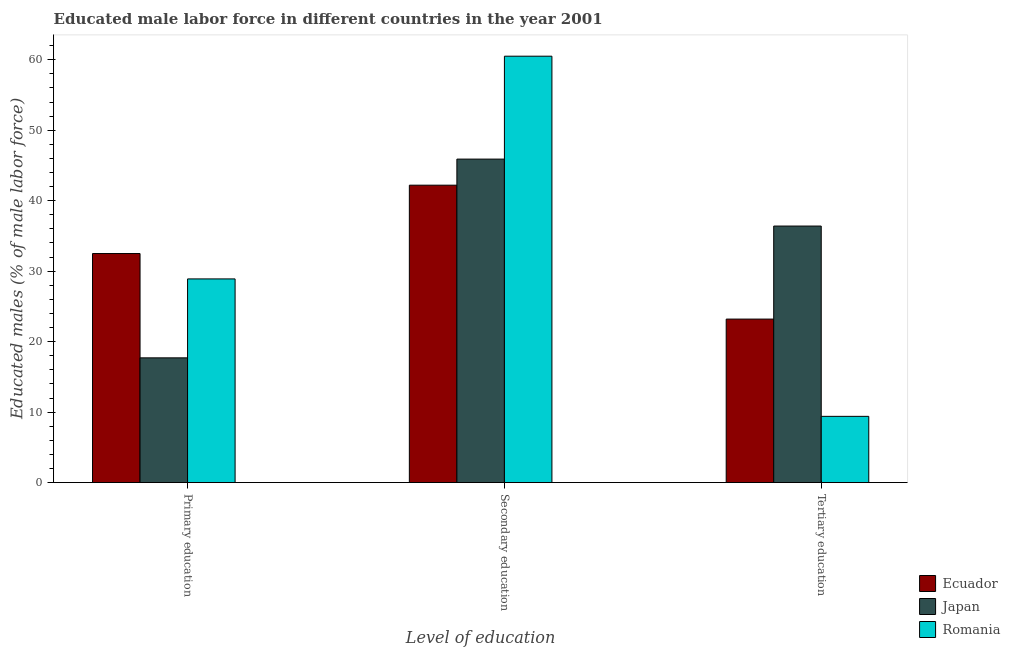How many different coloured bars are there?
Keep it short and to the point. 3. Are the number of bars per tick equal to the number of legend labels?
Your answer should be very brief. Yes. Are the number of bars on each tick of the X-axis equal?
Your answer should be compact. Yes. How many bars are there on the 1st tick from the left?
Your answer should be very brief. 3. What is the label of the 2nd group of bars from the left?
Offer a terse response. Secondary education. What is the percentage of male labor force who received secondary education in Romania?
Offer a very short reply. 60.5. Across all countries, what is the maximum percentage of male labor force who received primary education?
Offer a terse response. 32.5. Across all countries, what is the minimum percentage of male labor force who received tertiary education?
Offer a terse response. 9.4. In which country was the percentage of male labor force who received tertiary education maximum?
Offer a terse response. Japan. What is the total percentage of male labor force who received tertiary education in the graph?
Offer a very short reply. 69. What is the difference between the percentage of male labor force who received tertiary education in Romania and that in Japan?
Your answer should be compact. -27. What is the difference between the percentage of male labor force who received secondary education in Romania and the percentage of male labor force who received primary education in Japan?
Ensure brevity in your answer.  42.8. What is the average percentage of male labor force who received primary education per country?
Ensure brevity in your answer.  26.37. What is the difference between the percentage of male labor force who received tertiary education and percentage of male labor force who received primary education in Japan?
Make the answer very short. 18.7. What is the ratio of the percentage of male labor force who received tertiary education in Romania to that in Ecuador?
Offer a terse response. 0.41. Is the difference between the percentage of male labor force who received secondary education in Japan and Ecuador greater than the difference between the percentage of male labor force who received tertiary education in Japan and Ecuador?
Offer a very short reply. No. What is the difference between the highest and the second highest percentage of male labor force who received primary education?
Provide a short and direct response. 3.6. What is the difference between the highest and the lowest percentage of male labor force who received primary education?
Your answer should be compact. 14.8. What does the 2nd bar from the left in Tertiary education represents?
Provide a succinct answer. Japan. What does the 3rd bar from the right in Primary education represents?
Give a very brief answer. Ecuador. How many bars are there?
Provide a succinct answer. 9. Does the graph contain grids?
Your answer should be very brief. No. How are the legend labels stacked?
Offer a very short reply. Vertical. What is the title of the graph?
Give a very brief answer. Educated male labor force in different countries in the year 2001. Does "Slovak Republic" appear as one of the legend labels in the graph?
Provide a succinct answer. No. What is the label or title of the X-axis?
Give a very brief answer. Level of education. What is the label or title of the Y-axis?
Offer a very short reply. Educated males (% of male labor force). What is the Educated males (% of male labor force) of Ecuador in Primary education?
Keep it short and to the point. 32.5. What is the Educated males (% of male labor force) in Japan in Primary education?
Provide a short and direct response. 17.7. What is the Educated males (% of male labor force) in Romania in Primary education?
Provide a short and direct response. 28.9. What is the Educated males (% of male labor force) of Ecuador in Secondary education?
Provide a short and direct response. 42.2. What is the Educated males (% of male labor force) of Japan in Secondary education?
Ensure brevity in your answer.  45.9. What is the Educated males (% of male labor force) in Romania in Secondary education?
Offer a very short reply. 60.5. What is the Educated males (% of male labor force) of Ecuador in Tertiary education?
Your answer should be very brief. 23.2. What is the Educated males (% of male labor force) in Japan in Tertiary education?
Your answer should be compact. 36.4. What is the Educated males (% of male labor force) in Romania in Tertiary education?
Keep it short and to the point. 9.4. Across all Level of education, what is the maximum Educated males (% of male labor force) of Ecuador?
Keep it short and to the point. 42.2. Across all Level of education, what is the maximum Educated males (% of male labor force) in Japan?
Ensure brevity in your answer.  45.9. Across all Level of education, what is the maximum Educated males (% of male labor force) of Romania?
Make the answer very short. 60.5. Across all Level of education, what is the minimum Educated males (% of male labor force) of Ecuador?
Make the answer very short. 23.2. Across all Level of education, what is the minimum Educated males (% of male labor force) of Japan?
Make the answer very short. 17.7. Across all Level of education, what is the minimum Educated males (% of male labor force) in Romania?
Provide a succinct answer. 9.4. What is the total Educated males (% of male labor force) of Ecuador in the graph?
Offer a terse response. 97.9. What is the total Educated males (% of male labor force) in Romania in the graph?
Offer a terse response. 98.8. What is the difference between the Educated males (% of male labor force) of Ecuador in Primary education and that in Secondary education?
Keep it short and to the point. -9.7. What is the difference between the Educated males (% of male labor force) in Japan in Primary education and that in Secondary education?
Offer a very short reply. -28.2. What is the difference between the Educated males (% of male labor force) in Romania in Primary education and that in Secondary education?
Give a very brief answer. -31.6. What is the difference between the Educated males (% of male labor force) of Japan in Primary education and that in Tertiary education?
Offer a terse response. -18.7. What is the difference between the Educated males (% of male labor force) in Romania in Primary education and that in Tertiary education?
Your answer should be very brief. 19.5. What is the difference between the Educated males (% of male labor force) in Ecuador in Secondary education and that in Tertiary education?
Offer a terse response. 19. What is the difference between the Educated males (% of male labor force) of Romania in Secondary education and that in Tertiary education?
Provide a succinct answer. 51.1. What is the difference between the Educated males (% of male labor force) in Ecuador in Primary education and the Educated males (% of male labor force) in Romania in Secondary education?
Offer a very short reply. -28. What is the difference between the Educated males (% of male labor force) in Japan in Primary education and the Educated males (% of male labor force) in Romania in Secondary education?
Offer a terse response. -42.8. What is the difference between the Educated males (% of male labor force) of Ecuador in Primary education and the Educated males (% of male labor force) of Romania in Tertiary education?
Your answer should be compact. 23.1. What is the difference between the Educated males (% of male labor force) in Ecuador in Secondary education and the Educated males (% of male labor force) in Romania in Tertiary education?
Your response must be concise. 32.8. What is the difference between the Educated males (% of male labor force) of Japan in Secondary education and the Educated males (% of male labor force) of Romania in Tertiary education?
Provide a succinct answer. 36.5. What is the average Educated males (% of male labor force) in Ecuador per Level of education?
Give a very brief answer. 32.63. What is the average Educated males (% of male labor force) of Japan per Level of education?
Provide a succinct answer. 33.33. What is the average Educated males (% of male labor force) of Romania per Level of education?
Your response must be concise. 32.93. What is the difference between the Educated males (% of male labor force) in Ecuador and Educated males (% of male labor force) in Japan in Primary education?
Provide a succinct answer. 14.8. What is the difference between the Educated males (% of male labor force) in Japan and Educated males (% of male labor force) in Romania in Primary education?
Offer a terse response. -11.2. What is the difference between the Educated males (% of male labor force) in Ecuador and Educated males (% of male labor force) in Romania in Secondary education?
Your answer should be very brief. -18.3. What is the difference between the Educated males (% of male labor force) of Japan and Educated males (% of male labor force) of Romania in Secondary education?
Provide a short and direct response. -14.6. What is the difference between the Educated males (% of male labor force) of Ecuador and Educated males (% of male labor force) of Japan in Tertiary education?
Provide a short and direct response. -13.2. What is the difference between the Educated males (% of male labor force) in Ecuador and Educated males (% of male labor force) in Romania in Tertiary education?
Provide a succinct answer. 13.8. What is the ratio of the Educated males (% of male labor force) of Ecuador in Primary education to that in Secondary education?
Make the answer very short. 0.77. What is the ratio of the Educated males (% of male labor force) of Japan in Primary education to that in Secondary education?
Make the answer very short. 0.39. What is the ratio of the Educated males (% of male labor force) in Romania in Primary education to that in Secondary education?
Your answer should be compact. 0.48. What is the ratio of the Educated males (% of male labor force) of Ecuador in Primary education to that in Tertiary education?
Offer a very short reply. 1.4. What is the ratio of the Educated males (% of male labor force) in Japan in Primary education to that in Tertiary education?
Ensure brevity in your answer.  0.49. What is the ratio of the Educated males (% of male labor force) of Romania in Primary education to that in Tertiary education?
Keep it short and to the point. 3.07. What is the ratio of the Educated males (% of male labor force) of Ecuador in Secondary education to that in Tertiary education?
Offer a very short reply. 1.82. What is the ratio of the Educated males (% of male labor force) of Japan in Secondary education to that in Tertiary education?
Give a very brief answer. 1.26. What is the ratio of the Educated males (% of male labor force) of Romania in Secondary education to that in Tertiary education?
Give a very brief answer. 6.44. What is the difference between the highest and the second highest Educated males (% of male labor force) of Romania?
Offer a terse response. 31.6. What is the difference between the highest and the lowest Educated males (% of male labor force) in Ecuador?
Offer a very short reply. 19. What is the difference between the highest and the lowest Educated males (% of male labor force) of Japan?
Your answer should be compact. 28.2. What is the difference between the highest and the lowest Educated males (% of male labor force) of Romania?
Provide a short and direct response. 51.1. 